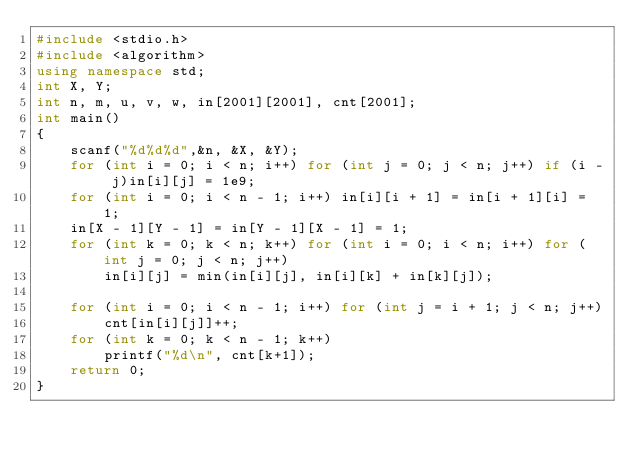Convert code to text. <code><loc_0><loc_0><loc_500><loc_500><_C++_>#include <stdio.h>
#include <algorithm>
using namespace std;
int X, Y;
int n, m, u, v, w, in[2001][2001], cnt[2001];
int main()
{
	scanf("%d%d%d",&n, &X, &Y);
	for (int i = 0; i < n; i++) for (int j = 0; j < n; j++) if (i - j)in[i][j] = 1e9;
	for (int i = 0; i < n - 1; i++) in[i][i + 1] = in[i + 1][i] = 1;
	in[X - 1][Y - 1] = in[Y - 1][X - 1] = 1;
	for (int k = 0; k < n; k++) for (int i = 0; i < n; i++) for (int j = 0; j < n; j++)
		in[i][j] = min(in[i][j], in[i][k] + in[k][j]);

	for (int i = 0; i < n - 1; i++) for (int j = i + 1; j < n; j++)
		cnt[in[i][j]]++;
	for (int k = 0; k < n - 1; k++)
		printf("%d\n", cnt[k+1]);
	return 0;
}
</code> 